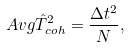<formula> <loc_0><loc_0><loc_500><loc_500>\ A v g { \hat { T } ^ { 2 } } _ { c o h } & = \frac { \Delta t ^ { 2 } } { N } ,</formula> 